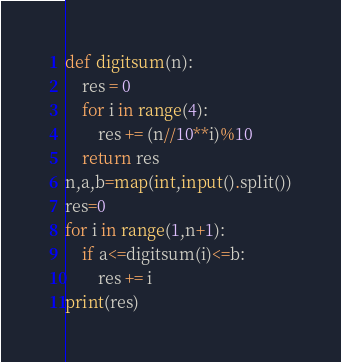<code> <loc_0><loc_0><loc_500><loc_500><_Python_>def digitsum(n):
    res = 0
    for i in range(4):
        res += (n//10**i)%10
    return res
n,a,b=map(int,input().split())
res=0
for i in range(1,n+1):
    if a<=digitsum(i)<=b:
        res += i
print(res)
</code> 